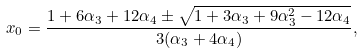<formula> <loc_0><loc_0><loc_500><loc_500>x _ { 0 } = \frac { 1 + 6 \alpha _ { 3 } + 1 2 \alpha _ { 4 } \pm \sqrt { 1 + 3 \alpha _ { 3 } + 9 \alpha _ { 3 } ^ { 2 } - 1 2 \alpha _ { 4 } } } { 3 ( \alpha _ { 3 } + 4 \alpha _ { 4 } ) } ,</formula> 